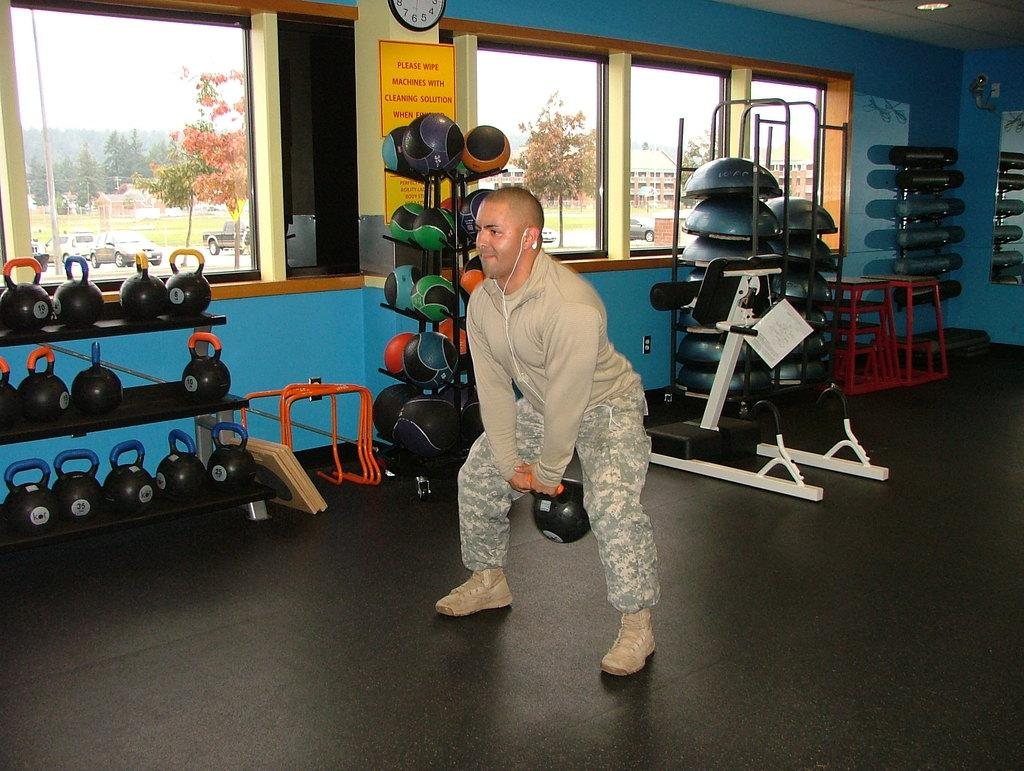<image>
Relay a brief, clear account of the picture shown. a man lifting weights with a please wipe sign nearby 